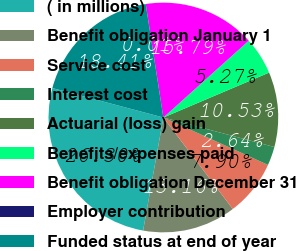Convert chart to OTSL. <chart><loc_0><loc_0><loc_500><loc_500><pie_chart><fcel>( in millions)<fcel>Benefit obligation January 1<fcel>Service cost<fcel>Interest cost<fcel>Actuarial (loss) gain<fcel>Benefits/expenses paid<fcel>Benefit obligation December 31<fcel>Employer contribution<fcel>Funded status at end of year<nl><fcel>26.31%<fcel>13.16%<fcel>7.9%<fcel>2.64%<fcel>10.53%<fcel>5.27%<fcel>15.79%<fcel>0.01%<fcel>18.42%<nl></chart> 